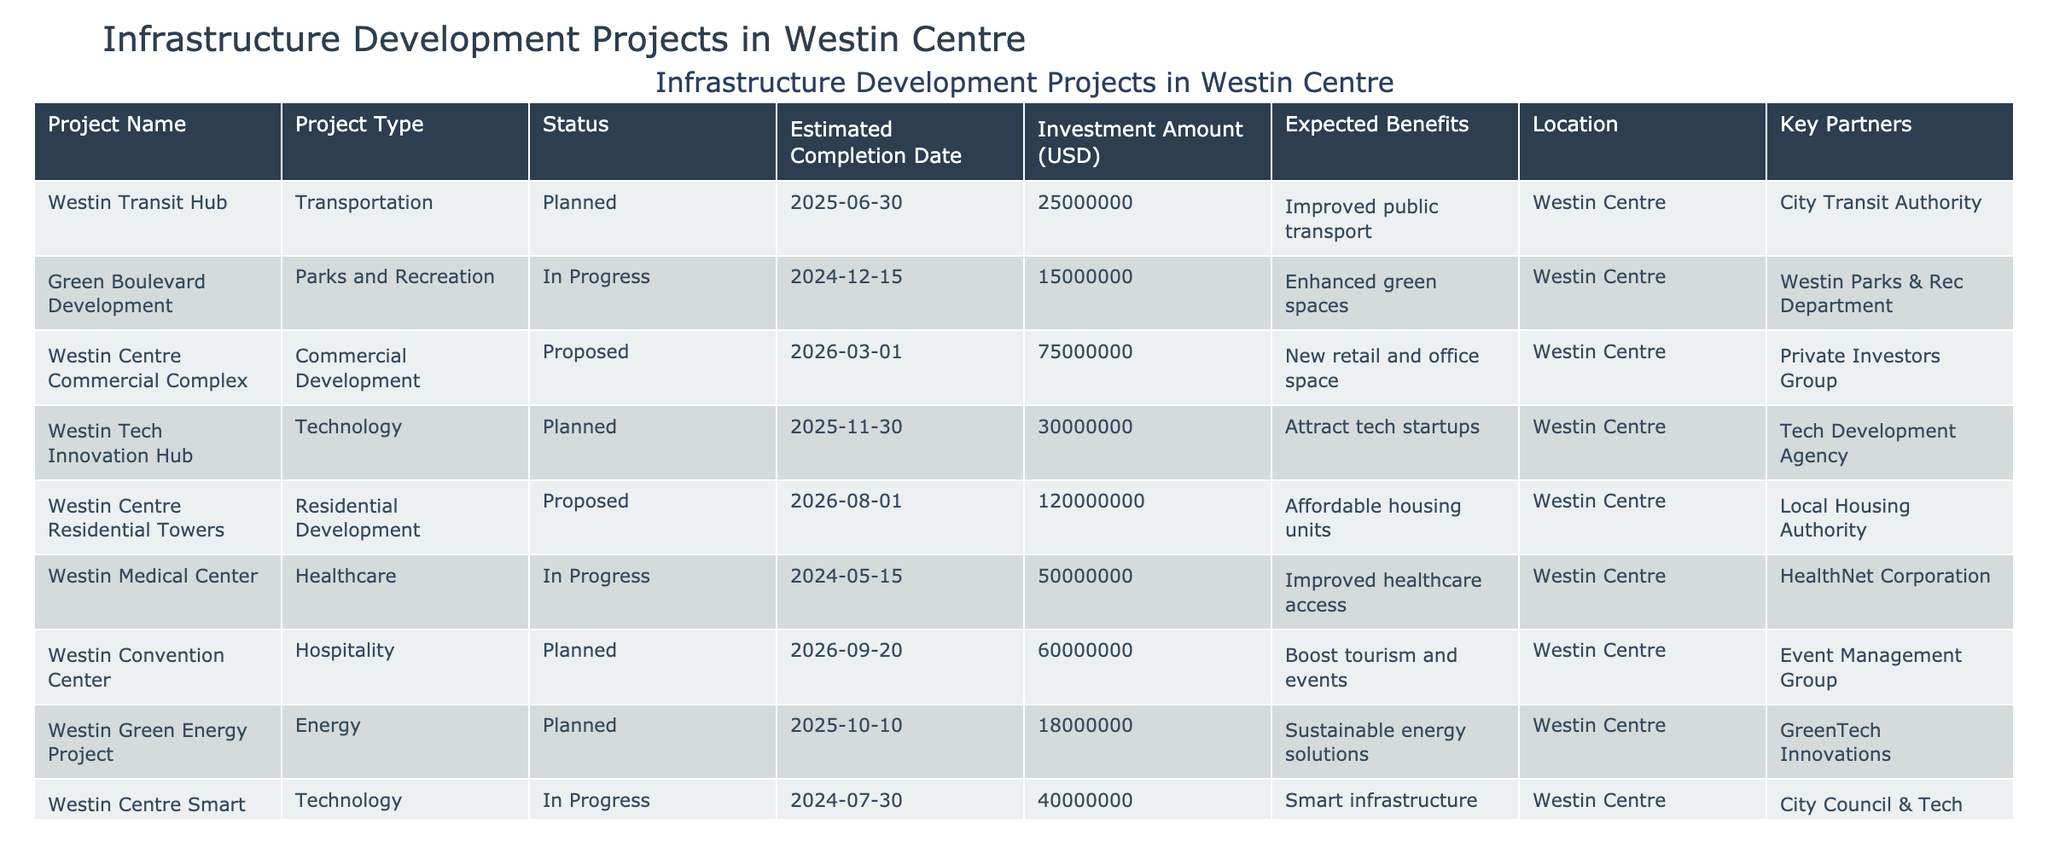What is the investment amount for the Westin Medical Center project? The investment amount is listed directly in the table under the "Investment Amount (USD)" column for the Westin Medical Center project. It shows $50,000,000.
Answer: 50,000,000 How many projects are in the Planned status? A count of the 'Status' column reveals three projects are marked as 'Planned': Westin Transit Hub, Westin Tech Innovation Hub, and Westin Green Energy Project.
Answer: 3 What is the expected benefit of the Westin Convention Center? The table specifies that the expected benefit of the Westin Convention Center project is to "Boost tourism and events."
Answer: Boost tourism and events Which project has the highest investment amount, and what is that amount? By comparing the investment amounts listed in the table, the Westin Centre Residential Towers has the highest investment at $120,000,000.
Answer: Westin Centre Residential Towers, 120,000,000 Are there any healthcare-related projects, and if so, what is their status? The Westin Medical Center is a healthcare project, and its status is 'In Progress,' as indicated in the status column.
Answer: Yes, In Progress What is the total estimated investment amount for all projects that are currently in progress? Summing the investment amounts for projects in progress (Green Boulevard Development $15,000,000 + Westin Medical Center $50,000,000 + Westin Centre Smart City Initiative $40,000,000) gives a total of $105,000,000.
Answer: 105,000,000 What are the expected benefits of the Westin Tech Innovation Hub? The table mentions that the expected benefit of the Westin Tech Innovation Hub project is to "Attract tech startups."
Answer: Attract tech startups Is the Westin Waterfront Development project proposed or planned? The status for the Westin Waterfront Development project is 'Planned,' as noted in the status column of the table.
Answer: Planned Which project has the latest estimated completion date, and when is it? By reviewing the 'Estimated Completion Date' column, the Westin Centre Residential Towers has the latest completion date of August 1, 2026.
Answer: Westin Centre Residential Towers, 2026-08-01 What is the difference in investment between the Westin Centre Commercial Complex and the Westin Tech Innovation Hub? The investment amount for the Westin Centre Commercial Complex is $75,000,000 and for the Westin Tech Innovation Hub is $30,000,000. The difference is $75,000,000 - $30,000,000 = $45,000,000.
Answer: 45,000,000 